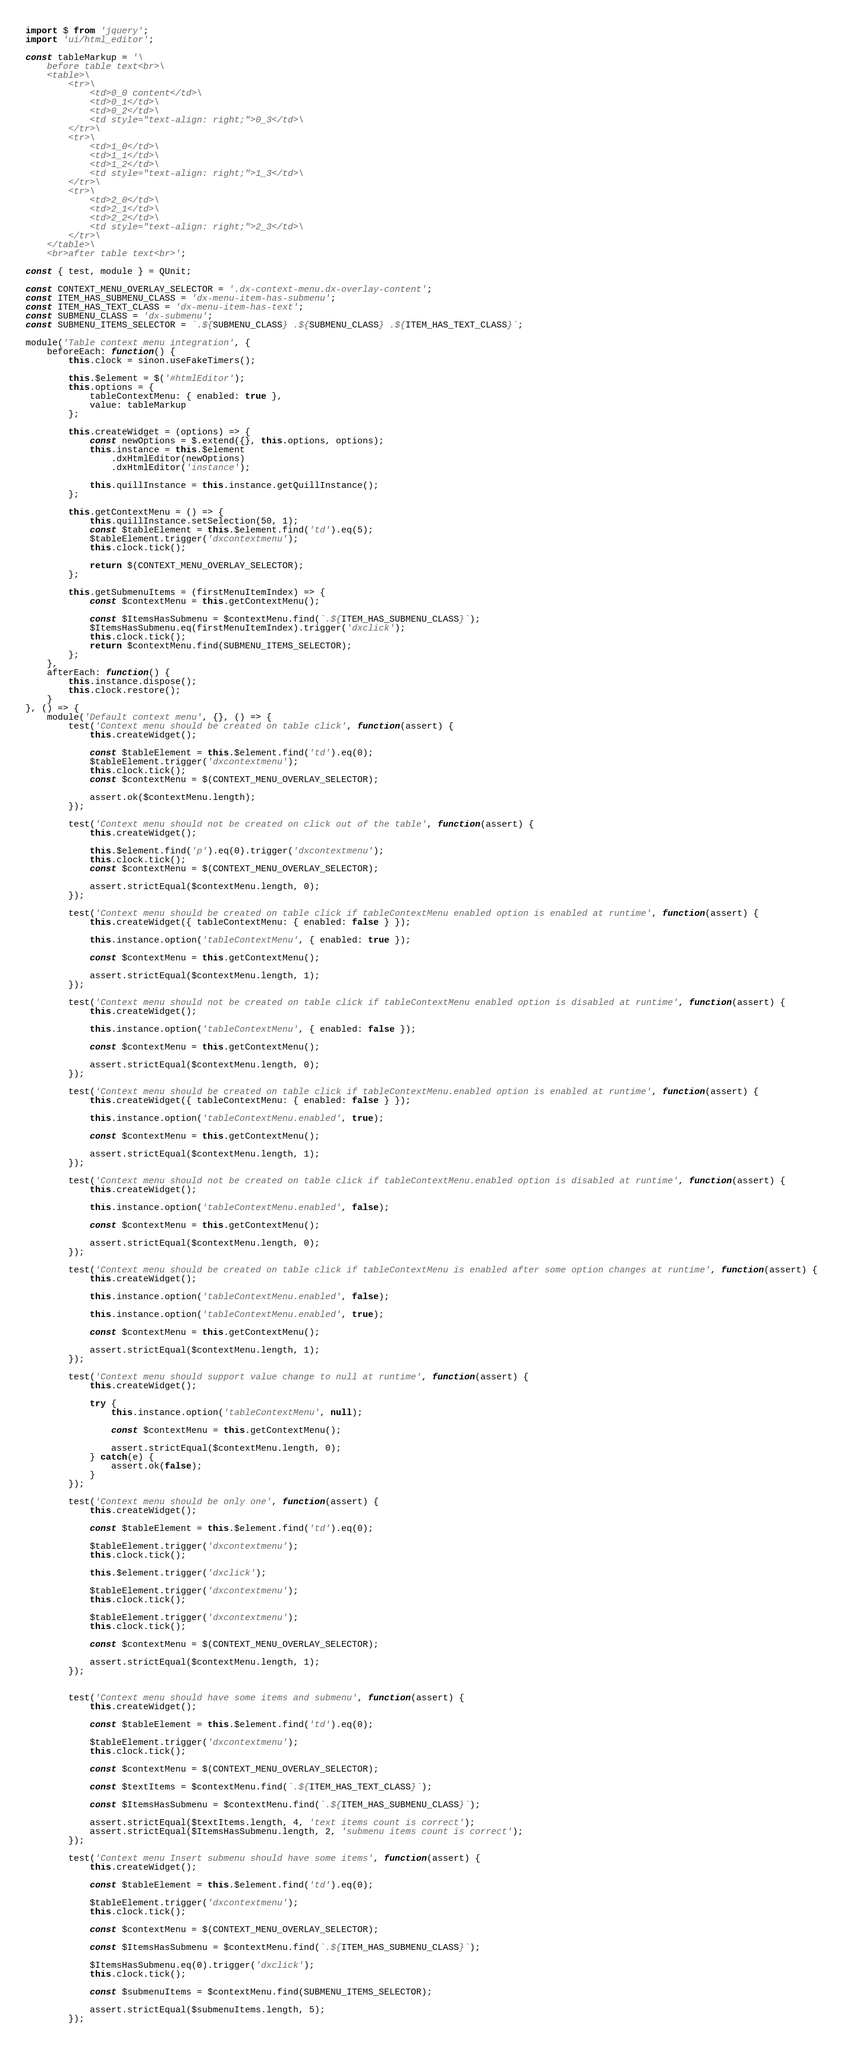Convert code to text. <code><loc_0><loc_0><loc_500><loc_500><_JavaScript_>import $ from 'jquery';
import 'ui/html_editor';

const tableMarkup = '\
    before table text<br>\
    <table>\
        <tr>\
            <td>0_0 content</td>\
            <td>0_1</td>\
            <td>0_2</td>\
            <td style="text-align: right;">0_3</td>\
        </tr>\
        <tr>\
            <td>1_0</td>\
            <td>1_1</td>\
            <td>1_2</td>\
            <td style="text-align: right;">1_3</td>\
        </tr>\
        <tr>\
            <td>2_0</td>\
            <td>2_1</td>\
            <td>2_2</td>\
            <td style="text-align: right;">2_3</td>\
        </tr>\
    </table>\
    <br>after table text<br>';

const { test, module } = QUnit;

const CONTEXT_MENU_OVERLAY_SELECTOR = '.dx-context-menu.dx-overlay-content';
const ITEM_HAS_SUBMENU_CLASS = 'dx-menu-item-has-submenu';
const ITEM_HAS_TEXT_CLASS = 'dx-menu-item-has-text';
const SUBMENU_CLASS = 'dx-submenu';
const SUBMENU_ITEMS_SELECTOR = `.${SUBMENU_CLASS} .${SUBMENU_CLASS} .${ITEM_HAS_TEXT_CLASS}`;

module('Table context menu integration', {
    beforeEach: function() {
        this.clock = sinon.useFakeTimers();

        this.$element = $('#htmlEditor');
        this.options = {
            tableContextMenu: { enabled: true },
            value: tableMarkup
        };

        this.createWidget = (options) => {
            const newOptions = $.extend({}, this.options, options);
            this.instance = this.$element
                .dxHtmlEditor(newOptions)
                .dxHtmlEditor('instance');

            this.quillInstance = this.instance.getQuillInstance();
        };

        this.getContextMenu = () => {
            this.quillInstance.setSelection(50, 1);
            const $tableElement = this.$element.find('td').eq(5);
            $tableElement.trigger('dxcontextmenu');
            this.clock.tick();

            return $(CONTEXT_MENU_OVERLAY_SELECTOR);
        };

        this.getSubmenuItems = (firstMenuItemIndex) => {
            const $contextMenu = this.getContextMenu();

            const $ItemsHasSubmenu = $contextMenu.find(`.${ITEM_HAS_SUBMENU_CLASS}`);
            $ItemsHasSubmenu.eq(firstMenuItemIndex).trigger('dxclick');
            this.clock.tick();
            return $contextMenu.find(SUBMENU_ITEMS_SELECTOR);
        };
    },
    afterEach: function() {
        this.instance.dispose();
        this.clock.restore();
    }
}, () => {
    module('Default context menu', {}, () => {
        test('Context menu should be created on table click', function(assert) {
            this.createWidget();

            const $tableElement = this.$element.find('td').eq(0);
            $tableElement.trigger('dxcontextmenu');
            this.clock.tick();
            const $contextMenu = $(CONTEXT_MENU_OVERLAY_SELECTOR);

            assert.ok($contextMenu.length);
        });

        test('Context menu should not be created on click out of the table', function(assert) {
            this.createWidget();

            this.$element.find('p').eq(0).trigger('dxcontextmenu');
            this.clock.tick();
            const $contextMenu = $(CONTEXT_MENU_OVERLAY_SELECTOR);

            assert.strictEqual($contextMenu.length, 0);
        });

        test('Context menu should be created on table click if tableContextMenu enabled option is enabled at runtime', function(assert) {
            this.createWidget({ tableContextMenu: { enabled: false } });

            this.instance.option('tableContextMenu', { enabled: true });

            const $contextMenu = this.getContextMenu();

            assert.strictEqual($contextMenu.length, 1);
        });

        test('Context menu should not be created on table click if tableContextMenu enabled option is disabled at runtime', function(assert) {
            this.createWidget();

            this.instance.option('tableContextMenu', { enabled: false });

            const $contextMenu = this.getContextMenu();

            assert.strictEqual($contextMenu.length, 0);
        });

        test('Context menu should be created on table click if tableContextMenu.enabled option is enabled at runtime', function(assert) {
            this.createWidget({ tableContextMenu: { enabled: false } });

            this.instance.option('tableContextMenu.enabled', true);

            const $contextMenu = this.getContextMenu();

            assert.strictEqual($contextMenu.length, 1);
        });

        test('Context menu should not be created on table click if tableContextMenu.enabled option is disabled at runtime', function(assert) {
            this.createWidget();

            this.instance.option('tableContextMenu.enabled', false);

            const $contextMenu = this.getContextMenu();

            assert.strictEqual($contextMenu.length, 0);
        });

        test('Context menu should be created on table click if tableContextMenu is enabled after some option changes at runtime', function(assert) {
            this.createWidget();

            this.instance.option('tableContextMenu.enabled', false);

            this.instance.option('tableContextMenu.enabled', true);

            const $contextMenu = this.getContextMenu();

            assert.strictEqual($contextMenu.length, 1);
        });

        test('Context menu should support value change to null at runtime', function(assert) {
            this.createWidget();

            try {
                this.instance.option('tableContextMenu', null);

                const $contextMenu = this.getContextMenu();

                assert.strictEqual($contextMenu.length, 0);
            } catch(e) {
                assert.ok(false);
            }
        });

        test('Context menu should be only one', function(assert) {
            this.createWidget();

            const $tableElement = this.$element.find('td').eq(0);

            $tableElement.trigger('dxcontextmenu');
            this.clock.tick();

            this.$element.trigger('dxclick');

            $tableElement.trigger('dxcontextmenu');
            this.clock.tick();

            $tableElement.trigger('dxcontextmenu');
            this.clock.tick();

            const $contextMenu = $(CONTEXT_MENU_OVERLAY_SELECTOR);

            assert.strictEqual($contextMenu.length, 1);
        });


        test('Context menu should have some items and submenu', function(assert) {
            this.createWidget();

            const $tableElement = this.$element.find('td').eq(0);

            $tableElement.trigger('dxcontextmenu');
            this.clock.tick();

            const $contextMenu = $(CONTEXT_MENU_OVERLAY_SELECTOR);

            const $textItems = $contextMenu.find(`.${ITEM_HAS_TEXT_CLASS}`);

            const $ItemsHasSubmenu = $contextMenu.find(`.${ITEM_HAS_SUBMENU_CLASS}`);

            assert.strictEqual($textItems.length, 4, 'text items count is correct');
            assert.strictEqual($ItemsHasSubmenu.length, 2, 'submenu items count is correct');
        });

        test('Context menu Insert submenu should have some items', function(assert) {
            this.createWidget();

            const $tableElement = this.$element.find('td').eq(0);

            $tableElement.trigger('dxcontextmenu');
            this.clock.tick();

            const $contextMenu = $(CONTEXT_MENU_OVERLAY_SELECTOR);

            const $ItemsHasSubmenu = $contextMenu.find(`.${ITEM_HAS_SUBMENU_CLASS}`);

            $ItemsHasSubmenu.eq(0).trigger('dxclick');
            this.clock.tick();

            const $submenuItems = $contextMenu.find(SUBMENU_ITEMS_SELECTOR);

            assert.strictEqual($submenuItems.length, 5);
        });
</code> 